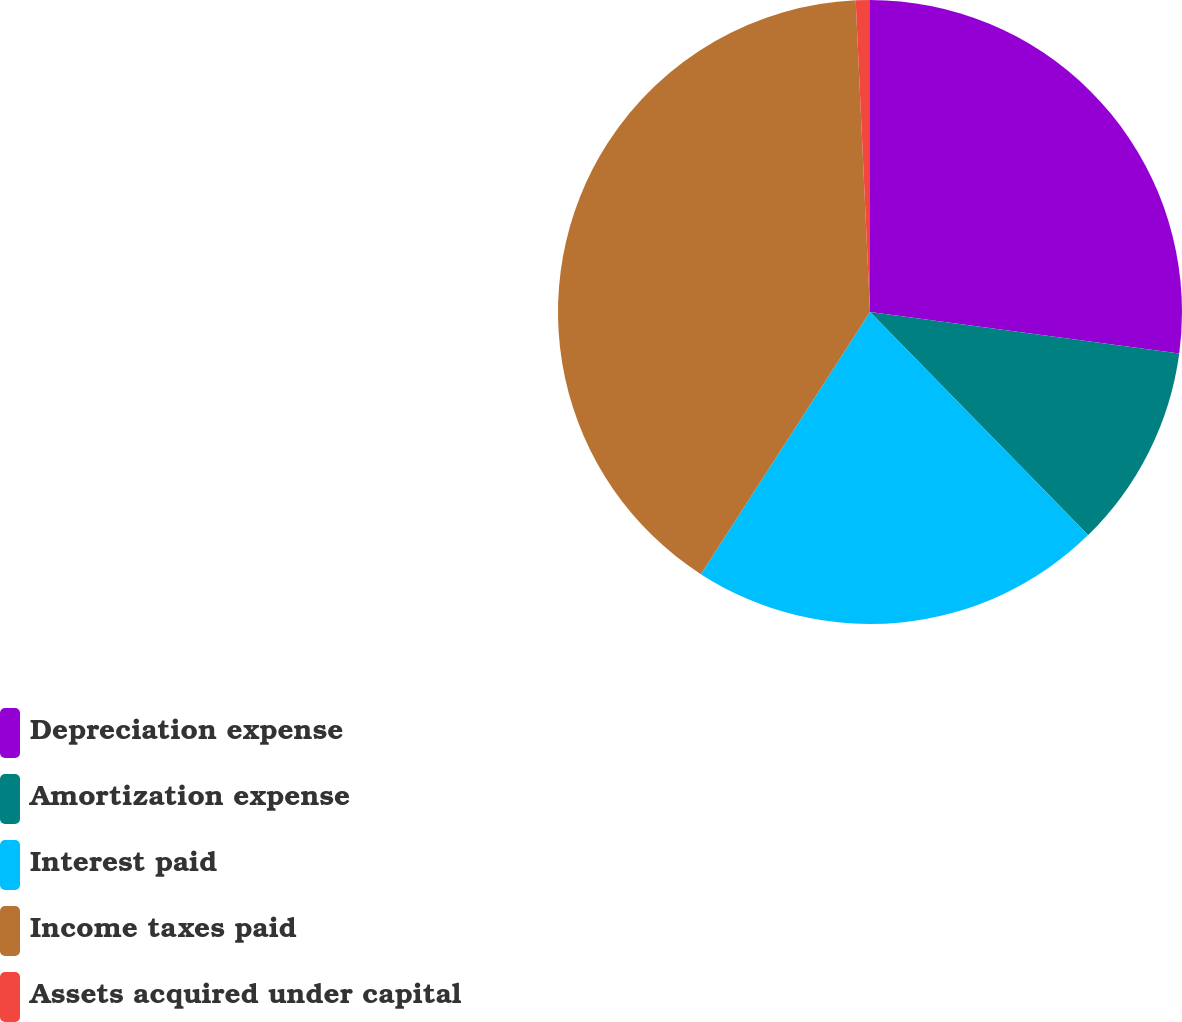<chart> <loc_0><loc_0><loc_500><loc_500><pie_chart><fcel>Depreciation expense<fcel>Amortization expense<fcel>Interest paid<fcel>Income taxes paid<fcel>Assets acquired under capital<nl><fcel>27.12%<fcel>10.56%<fcel>21.44%<fcel>40.15%<fcel>0.73%<nl></chart> 